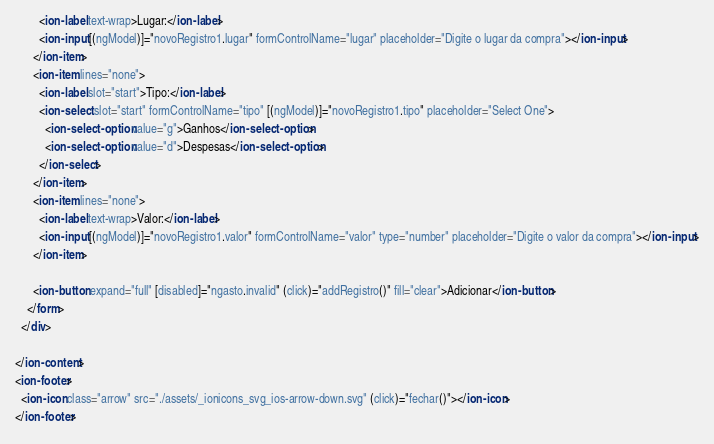<code> <loc_0><loc_0><loc_500><loc_500><_HTML_>        <ion-label text-wrap>Lugar:</ion-label>
        <ion-input [(ngModel)]="novoRegistro1.lugar" formControlName="lugar" placeholder="Digite o lugar da compra"></ion-input>
      </ion-item>
      <ion-item lines="none">
        <ion-label slot="start">Tipo:</ion-label>
        <ion-select slot="start" formControlName="tipo" [(ngModel)]="novoRegistro1.tipo" placeholder="Select One">
          <ion-select-option value="g">Ganhos</ion-select-option>
          <ion-select-option value="d">Despesas</ion-select-option>
        </ion-select>
      </ion-item>
      <ion-item lines="none">
        <ion-label text-wrap>Valor:</ion-label>
        <ion-input [(ngModel)]="novoRegistro1.valor" formControlName="valor" type="number" placeholder="Digite o valor da compra"></ion-input>
      </ion-item>

      <ion-button expand="full" [disabled]="ngasto.invalid" (click)="addRegistro()" fill="clear">Adicionar</ion-button>
    </form>
  </div>

</ion-content>
<ion-footer>
  <ion-icon class="arrow" src="./assets/_ionicons_svg_ios-arrow-down.svg" (click)="fechar()"></ion-icon>
</ion-footer></code> 